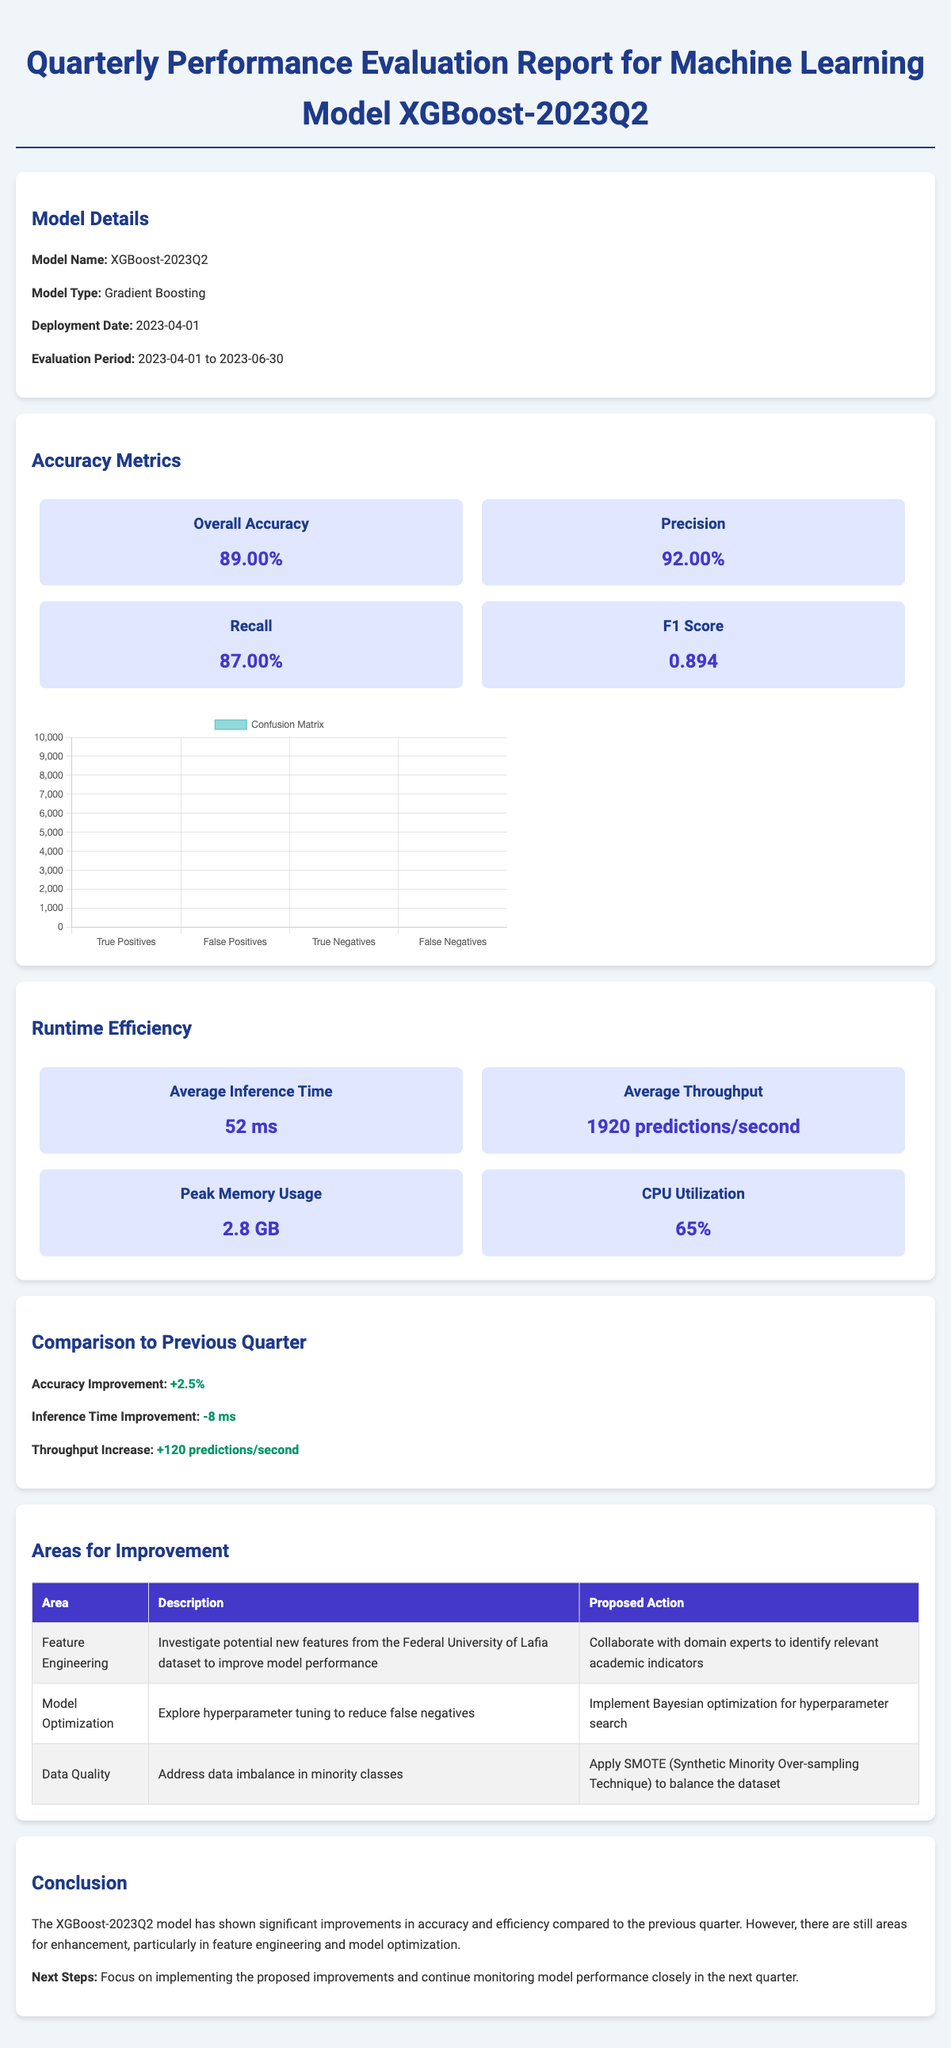what is the overall accuracy? The overall accuracy is provided in the accuracy metrics section of the document, listed as 0.89.
Answer: 0.89 what is the average inference time? The average inference time is mentioned in the runtime efficiency section, which indicates it takes 52 milliseconds.
Answer: 52 ms who led feature engineering efforts? The team contributions section specifies that Amina Ibrahim led the feature engineering efforts.
Answer: Amina Ibrahim what is the proposed action for data imbalance? The areas for improvement section outlines the proposed action to apply SMOTE to balance the dataset.
Answer: Apply SMOTE how much did the accuracy improve compared to the previous quarter? The document reports an accuracy improvement of +2.5% from the previous quarter.
Answer: +2.5% which cloud provider is used for deployment? The deployment environment section mentions that the cloud provider is Amazon Web Services (AWS).
Answer: Amazon Web Services what is the peak memory usage of the model? The runtime efficiency data indicates that the peak memory usage is 2.8 GB.
Answer: 2.8 GB what is the next step mentioned in the conclusion? The next steps from the conclusion suggest focusing on implementing the proposed improvements.
Answer: Implementing proposed improvements how many alerts were triggered for dataset drift detection? The monitoring and alerts section states that 2 alerts were triggered for dataset drift detection.
Answer: 2 